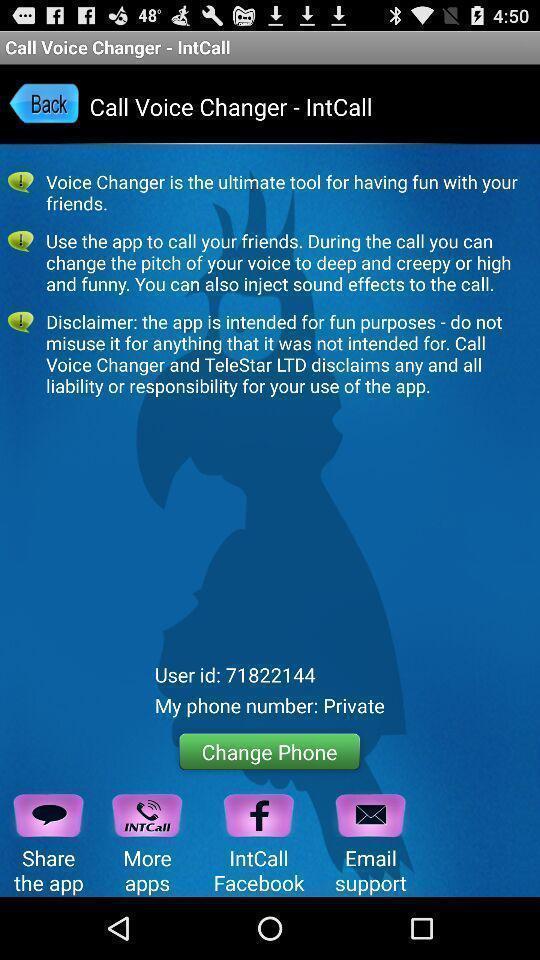What is the overall content of this screenshot? Screen shows call voice changer details. 